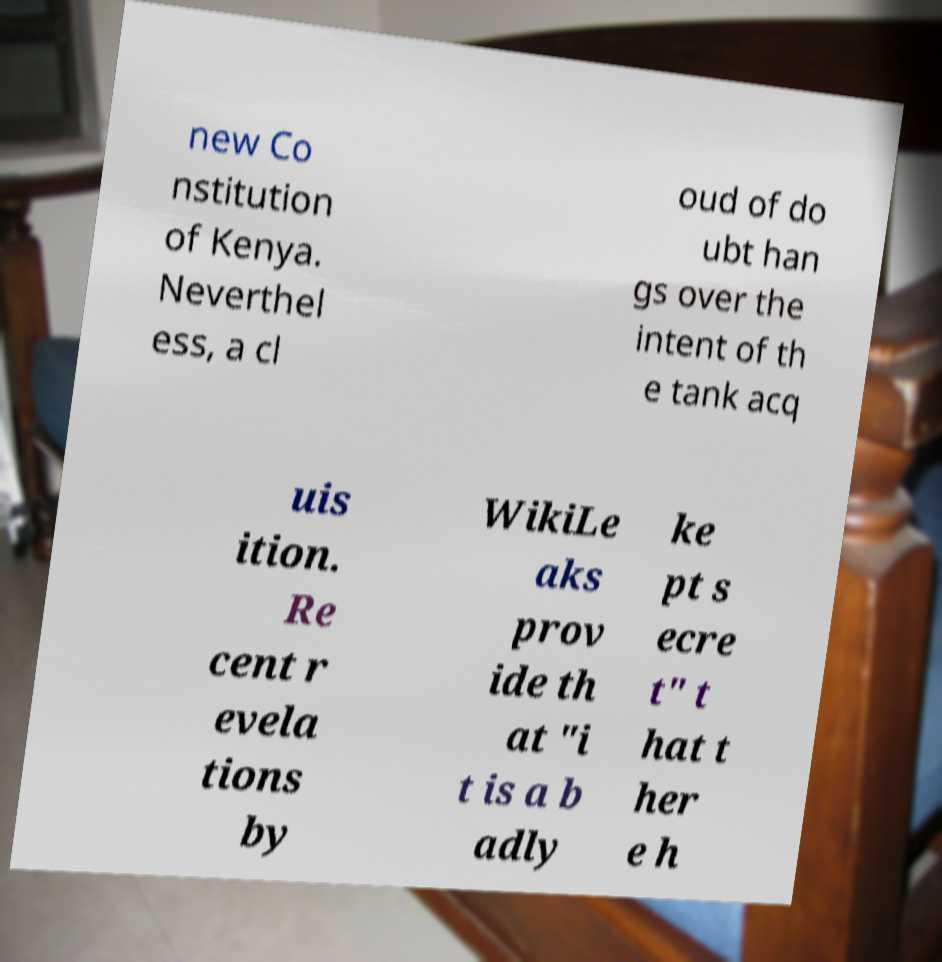What messages or text are displayed in this image? I need them in a readable, typed format. new Co nstitution of Kenya. Neverthel ess, a cl oud of do ubt han gs over the intent of th e tank acq uis ition. Re cent r evela tions by WikiLe aks prov ide th at "i t is a b adly ke pt s ecre t" t hat t her e h 